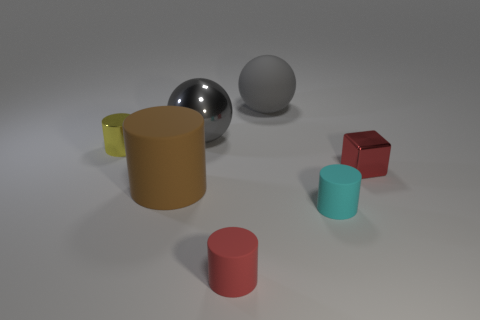Subtract 1 cylinders. How many cylinders are left? 3 Subtract all purple cubes. Subtract all blue balls. How many cubes are left? 1 Add 3 tiny rubber things. How many objects exist? 10 Subtract all cubes. How many objects are left? 6 Add 1 large gray metal spheres. How many large gray metal spheres are left? 2 Add 5 yellow metal things. How many yellow metal things exist? 6 Subtract 0 yellow balls. How many objects are left? 7 Subtract all small red shiny things. Subtract all small red metallic blocks. How many objects are left? 5 